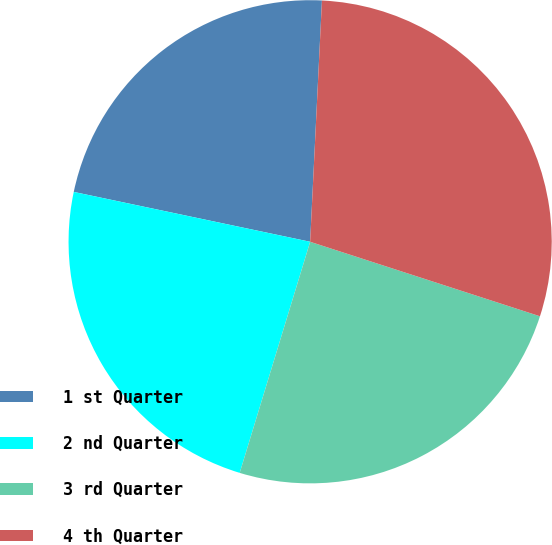Convert chart to OTSL. <chart><loc_0><loc_0><loc_500><loc_500><pie_chart><fcel>1 st Quarter<fcel>2 nd Quarter<fcel>3 rd Quarter<fcel>4 th Quarter<nl><fcel>22.47%<fcel>23.6%<fcel>24.72%<fcel>29.21%<nl></chart> 